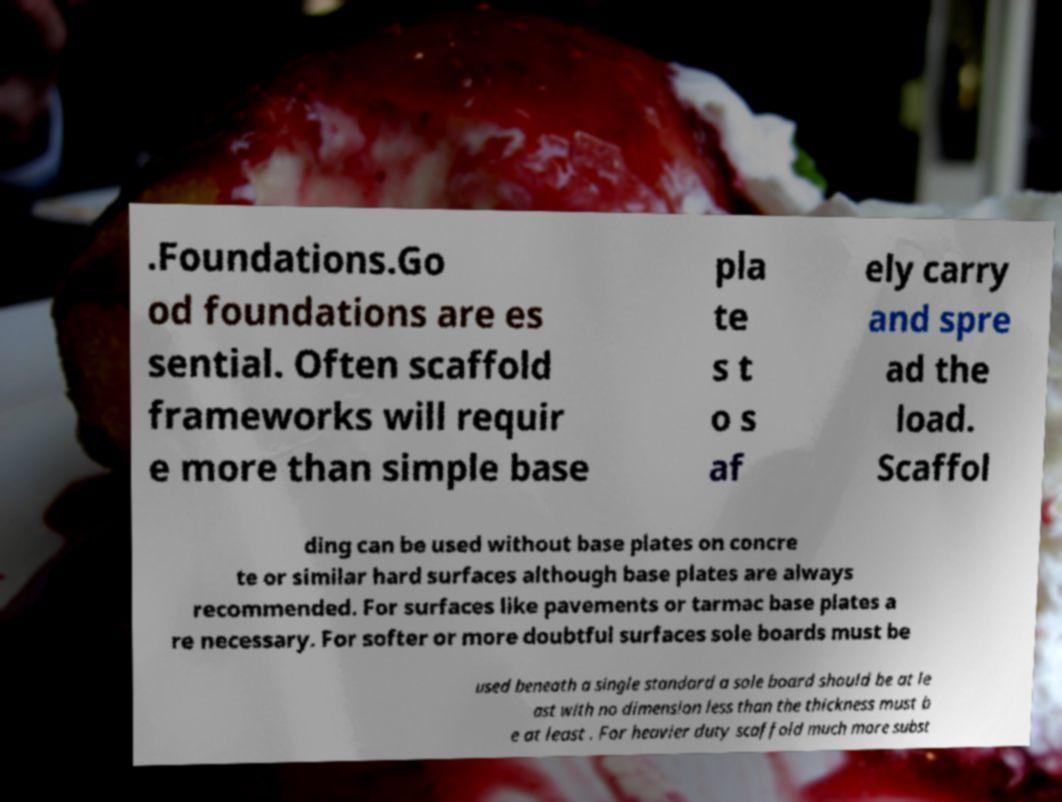There's text embedded in this image that I need extracted. Can you transcribe it verbatim? .Foundations.Go od foundations are es sential. Often scaffold frameworks will requir e more than simple base pla te s t o s af ely carry and spre ad the load. Scaffol ding can be used without base plates on concre te or similar hard surfaces although base plates are always recommended. For surfaces like pavements or tarmac base plates a re necessary. For softer or more doubtful surfaces sole boards must be used beneath a single standard a sole board should be at le ast with no dimension less than the thickness must b e at least . For heavier duty scaffold much more subst 